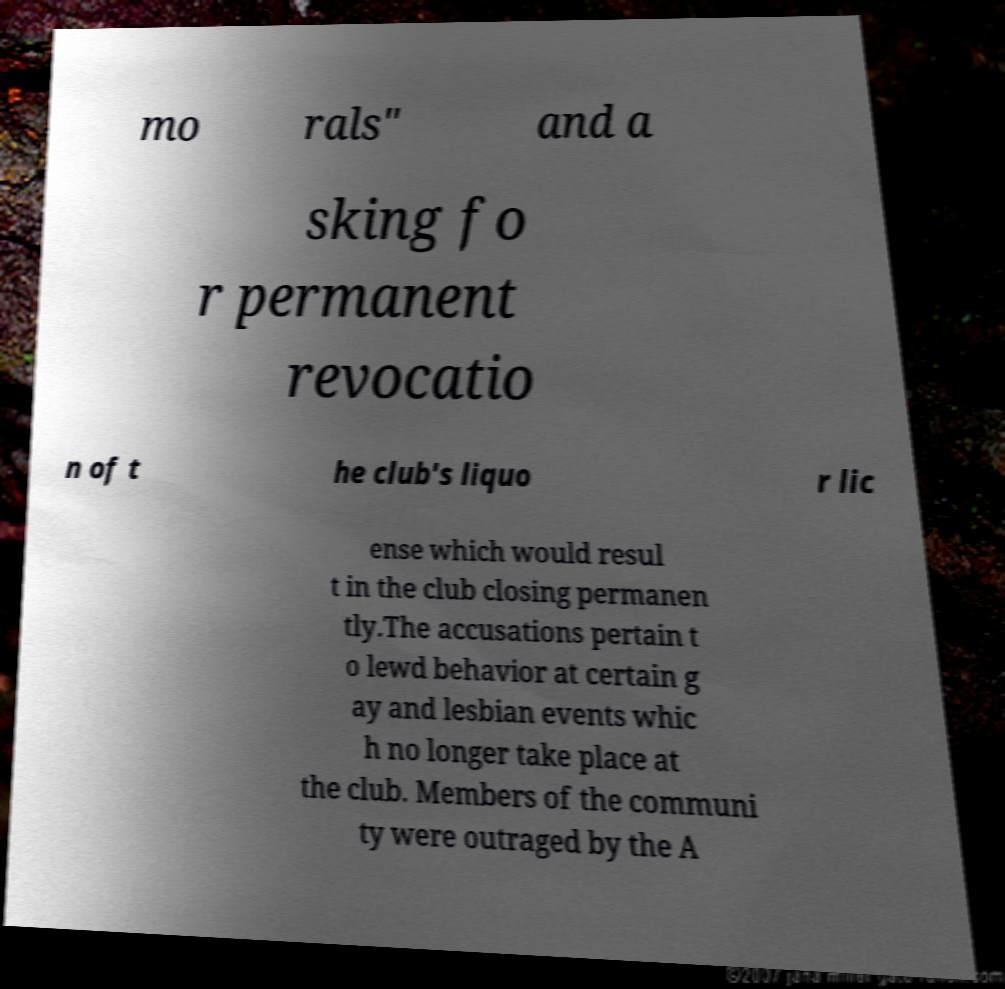Please read and relay the text visible in this image. What does it say? mo rals" and a sking fo r permanent revocatio n of t he club's liquo r lic ense which would resul t in the club closing permanen tly.The accusations pertain t o lewd behavior at certain g ay and lesbian events whic h no longer take place at the club. Members of the communi ty were outraged by the A 